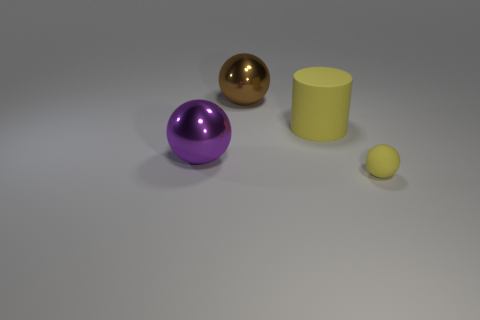Add 3 purple things. How many objects exist? 7 Subtract all brown shiny balls. How many balls are left? 2 Subtract all spheres. How many objects are left? 1 Subtract all small yellow matte spheres. Subtract all big purple cylinders. How many objects are left? 3 Add 2 brown balls. How many brown balls are left? 3 Add 2 large purple metallic things. How many large purple metallic things exist? 3 Subtract all yellow balls. How many balls are left? 2 Subtract 1 yellow balls. How many objects are left? 3 Subtract 2 spheres. How many spheres are left? 1 Subtract all green spheres. Subtract all gray cubes. How many spheres are left? 3 